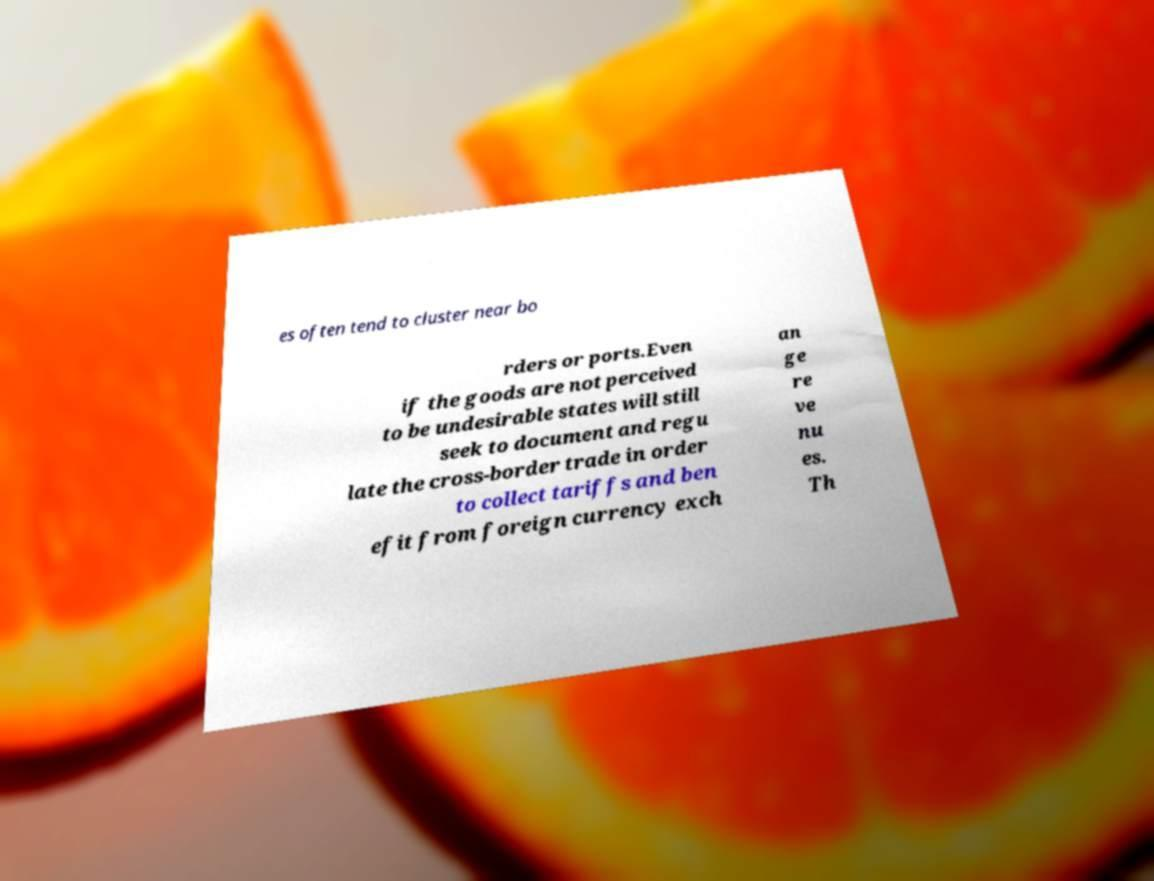Could you extract and type out the text from this image? es often tend to cluster near bo rders or ports.Even if the goods are not perceived to be undesirable states will still seek to document and regu late the cross-border trade in order to collect tariffs and ben efit from foreign currency exch an ge re ve nu es. Th 